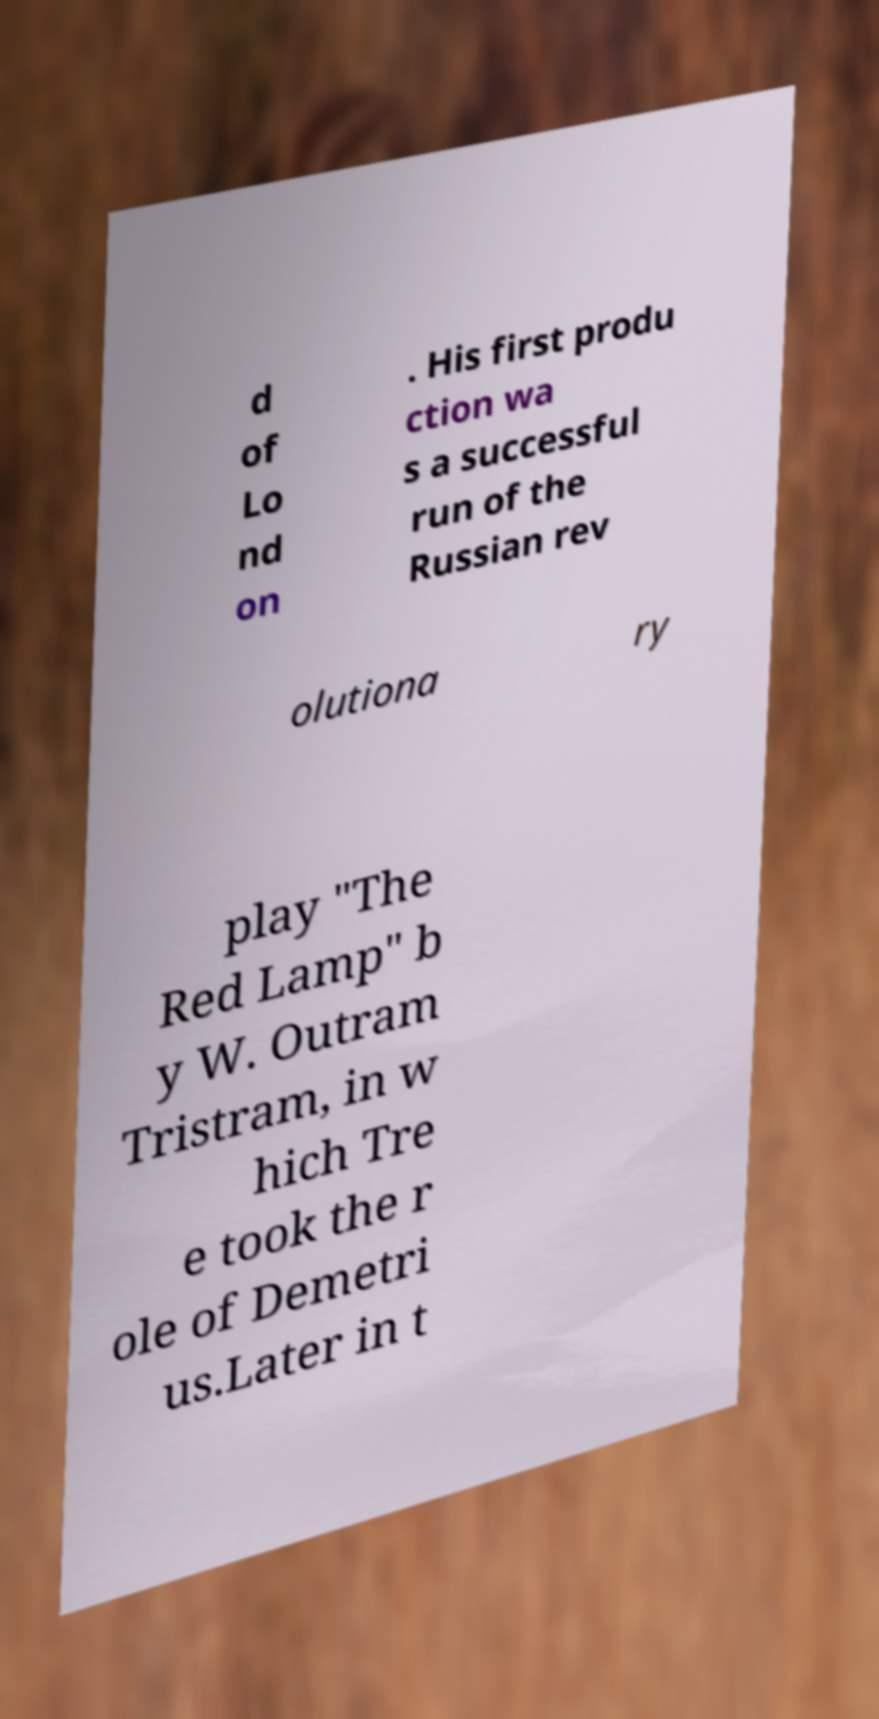Can you accurately transcribe the text from the provided image for me? d of Lo nd on . His first produ ction wa s a successful run of the Russian rev olutiona ry play "The Red Lamp" b y W. Outram Tristram, in w hich Tre e took the r ole of Demetri us.Later in t 